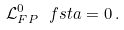Convert formula to latex. <formula><loc_0><loc_0><loc_500><loc_500>\mathcal { L } ^ { 0 } _ { F P } \ f s t a = 0 \, .</formula> 